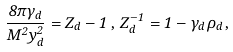Convert formula to latex. <formula><loc_0><loc_0><loc_500><loc_500>\frac { 8 \pi \gamma _ { d } } { M ^ { 2 } y ^ { 2 } _ { d } } = Z _ { d } - 1 \, , \, Z _ { d } ^ { - 1 } = 1 - \gamma _ { d } \rho _ { d } \, ,</formula> 